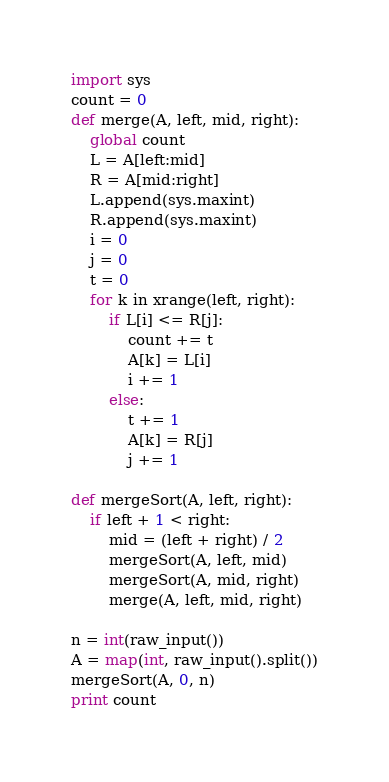Convert code to text. <code><loc_0><loc_0><loc_500><loc_500><_Python_>import sys
count = 0
def merge(A, left, mid, right):
    global count
    L = A[left:mid]
    R = A[mid:right]
    L.append(sys.maxint)
    R.append(sys.maxint)
    i = 0
    j = 0
    t = 0
    for k in xrange(left, right):
        if L[i] <= R[j]:
            count += t
            A[k] = L[i]
            i += 1
        else:
            t += 1
            A[k] = R[j]
            j += 1

def mergeSort(A, left, right):
    if left + 1 < right:
        mid = (left + right) / 2
        mergeSort(A, left, mid)
        mergeSort(A, mid, right)
        merge(A, left, mid, right)

n = int(raw_input())
A = map(int, raw_input().split())
mergeSort(A, 0, n)
print count</code> 